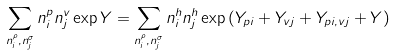<formula> <loc_0><loc_0><loc_500><loc_500>\sum _ { n ^ { \rho } _ { i } , n ^ { \sigma } _ { j } } n ^ { p } _ { i } n ^ { v } _ { j } \exp Y = \sum _ { n ^ { \rho } _ { i } , n ^ { \sigma } _ { j } } n ^ { h } _ { i } n ^ { h } _ { j } \exp \left ( Y _ { p i } + Y _ { v j } + Y _ { { p i } , v j } + Y \right )</formula> 